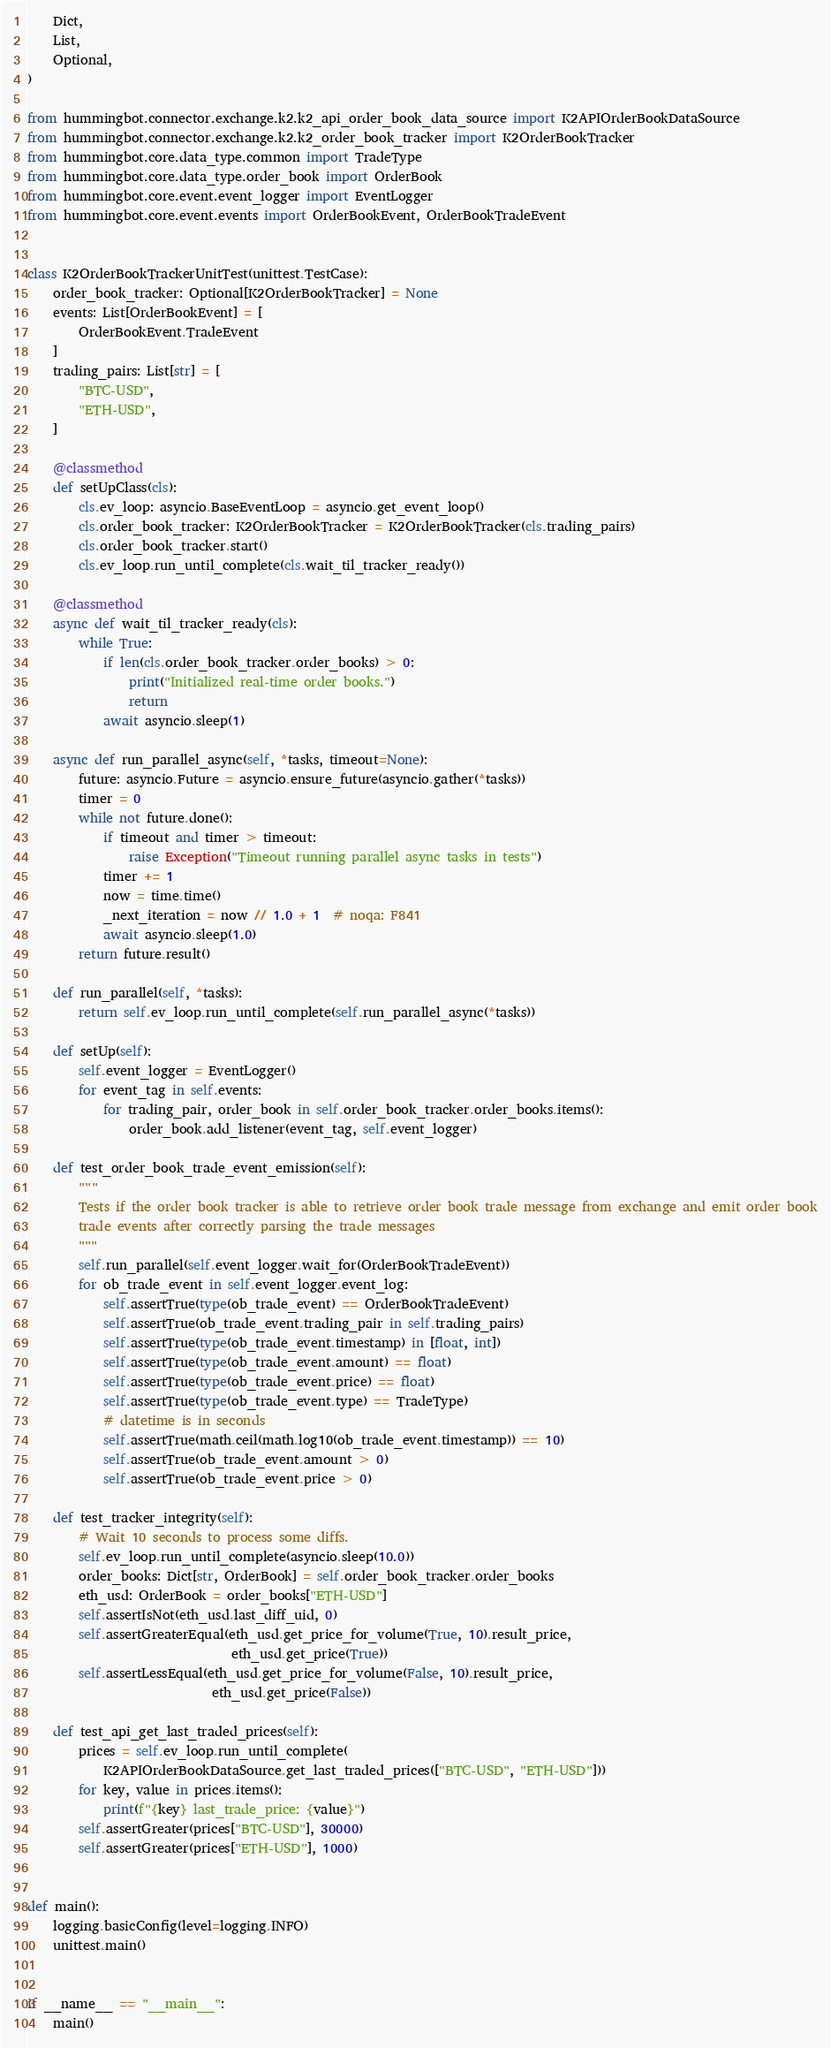<code> <loc_0><loc_0><loc_500><loc_500><_Python_>    Dict,
    List,
    Optional,
)

from hummingbot.connector.exchange.k2.k2_api_order_book_data_source import K2APIOrderBookDataSource
from hummingbot.connector.exchange.k2.k2_order_book_tracker import K2OrderBookTracker
from hummingbot.core.data_type.common import TradeType
from hummingbot.core.data_type.order_book import OrderBook
from hummingbot.core.event.event_logger import EventLogger
from hummingbot.core.event.events import OrderBookEvent, OrderBookTradeEvent


class K2OrderBookTrackerUnitTest(unittest.TestCase):
    order_book_tracker: Optional[K2OrderBookTracker] = None
    events: List[OrderBookEvent] = [
        OrderBookEvent.TradeEvent
    ]
    trading_pairs: List[str] = [
        "BTC-USD",
        "ETH-USD",
    ]

    @classmethod
    def setUpClass(cls):
        cls.ev_loop: asyncio.BaseEventLoop = asyncio.get_event_loop()
        cls.order_book_tracker: K2OrderBookTracker = K2OrderBookTracker(cls.trading_pairs)
        cls.order_book_tracker.start()
        cls.ev_loop.run_until_complete(cls.wait_til_tracker_ready())

    @classmethod
    async def wait_til_tracker_ready(cls):
        while True:
            if len(cls.order_book_tracker.order_books) > 0:
                print("Initialized real-time order books.")
                return
            await asyncio.sleep(1)

    async def run_parallel_async(self, *tasks, timeout=None):
        future: asyncio.Future = asyncio.ensure_future(asyncio.gather(*tasks))
        timer = 0
        while not future.done():
            if timeout and timer > timeout:
                raise Exception("Timeout running parallel async tasks in tests")
            timer += 1
            now = time.time()
            _next_iteration = now // 1.0 + 1  # noqa: F841
            await asyncio.sleep(1.0)
        return future.result()

    def run_parallel(self, *tasks):
        return self.ev_loop.run_until_complete(self.run_parallel_async(*tasks))

    def setUp(self):
        self.event_logger = EventLogger()
        for event_tag in self.events:
            for trading_pair, order_book in self.order_book_tracker.order_books.items():
                order_book.add_listener(event_tag, self.event_logger)

    def test_order_book_trade_event_emission(self):
        """
        Tests if the order book tracker is able to retrieve order book trade message from exchange and emit order book
        trade events after correctly parsing the trade messages
        """
        self.run_parallel(self.event_logger.wait_for(OrderBookTradeEvent))
        for ob_trade_event in self.event_logger.event_log:
            self.assertTrue(type(ob_trade_event) == OrderBookTradeEvent)
            self.assertTrue(ob_trade_event.trading_pair in self.trading_pairs)
            self.assertTrue(type(ob_trade_event.timestamp) in [float, int])
            self.assertTrue(type(ob_trade_event.amount) == float)
            self.assertTrue(type(ob_trade_event.price) == float)
            self.assertTrue(type(ob_trade_event.type) == TradeType)
            # datetime is in seconds
            self.assertTrue(math.ceil(math.log10(ob_trade_event.timestamp)) == 10)
            self.assertTrue(ob_trade_event.amount > 0)
            self.assertTrue(ob_trade_event.price > 0)

    def test_tracker_integrity(self):
        # Wait 10 seconds to process some diffs.
        self.ev_loop.run_until_complete(asyncio.sleep(10.0))
        order_books: Dict[str, OrderBook] = self.order_book_tracker.order_books
        eth_usd: OrderBook = order_books["ETH-USD"]
        self.assertIsNot(eth_usd.last_diff_uid, 0)
        self.assertGreaterEqual(eth_usd.get_price_for_volume(True, 10).result_price,
                                eth_usd.get_price(True))
        self.assertLessEqual(eth_usd.get_price_for_volume(False, 10).result_price,
                             eth_usd.get_price(False))

    def test_api_get_last_traded_prices(self):
        prices = self.ev_loop.run_until_complete(
            K2APIOrderBookDataSource.get_last_traded_prices(["BTC-USD", "ETH-USD"]))
        for key, value in prices.items():
            print(f"{key} last_trade_price: {value}")
        self.assertGreater(prices["BTC-USD"], 30000)
        self.assertGreater(prices["ETH-USD"], 1000)


def main():
    logging.basicConfig(level=logging.INFO)
    unittest.main()


if __name__ == "__main__":
    main()
</code> 